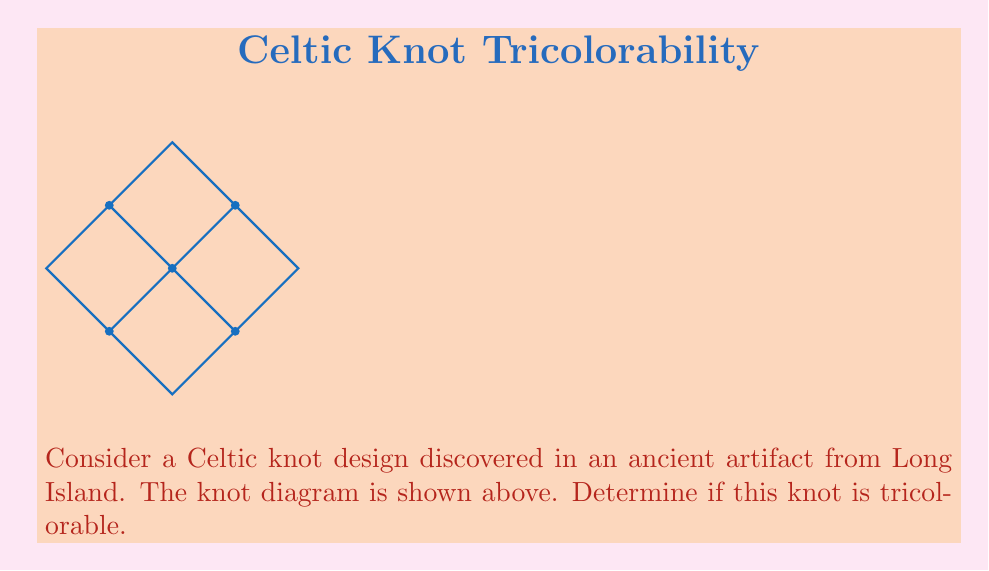Can you solve this math problem? To determine if a knot is tricolorable, we need to follow these steps:

1) Assign colors to the arcs of the knot diagram. We'll use red (R), blue (B), and green (G).

2) At each crossing, either all three colors must be present, or all arcs must have the same color.

3) If we can color the entire knot following these rules, it's tricolorable.

Let's color the knot:

Step 1: Assign R to the top-left arc.

Step 2: At the first crossing, we need to use all three colors. So, assign B to the under-arc and G to the top-right arc.

Step 3: Move to the next crossing (top-right). We have G coming in, so the under-arc must be R to match the existing R arc.

Step 4: Continue this process around the knot. We find that we can consistently color the knot following the rules:
- Top-left to bottom-right diagonal: R
- Top-right to bottom-left diagonal: G
- Horizontal arcs: B

Step 5: Verify that each crossing satisfies the tricolorability condition. Indeed, at each crossing, we have all three colors meeting.

Therefore, we have successfully tricolored the knot.

The tricolorability of a knot is an invariant, meaning it doesn't change regardless of how we deform the knot (as long as we don't cut and rejoin it). This property makes it useful for analyzing Celtic knots, which often have intricate designs but maintain their underlying structure.
Answer: Yes, the knot is tricolorable. 